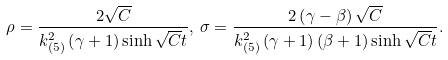Convert formula to latex. <formula><loc_0><loc_0><loc_500><loc_500>\rho = \frac { 2 \sqrt { C } } { k _ { ( 5 ) } ^ { 2 } \left ( \gamma + 1 \right ) \sinh { \sqrt { C } t } } , \, \sigma = \frac { 2 \left ( \gamma - \beta \right ) \sqrt { C } } { k _ { ( 5 ) } ^ { 2 } \left ( \gamma + 1 \right ) \left ( \beta + 1 \right ) { \sinh { \sqrt { C } t } } } .</formula> 